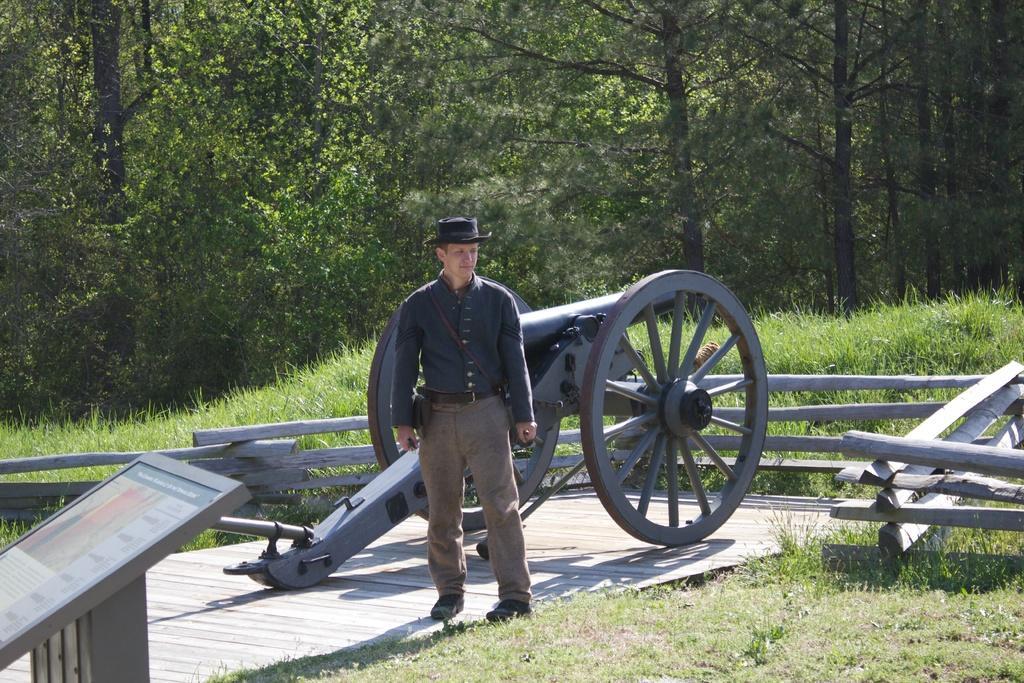How would you summarize this image in a sentence or two? In this image we can see a person standing in front of a cannon. We can also see a board, some grass, a wooden fence and a group of trees. 